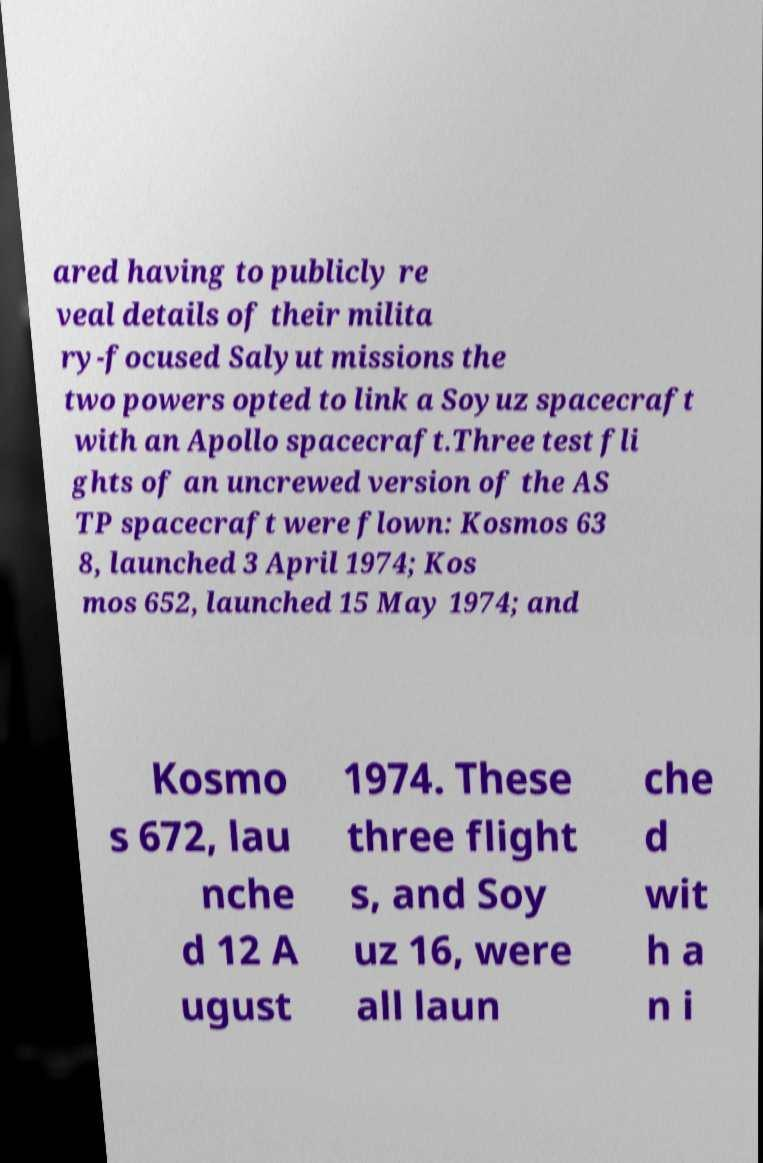Please read and relay the text visible in this image. What does it say? ared having to publicly re veal details of their milita ry-focused Salyut missions the two powers opted to link a Soyuz spacecraft with an Apollo spacecraft.Three test fli ghts of an uncrewed version of the AS TP spacecraft were flown: Kosmos 63 8, launched 3 April 1974; Kos mos 652, launched 15 May 1974; and Kosmo s 672, lau nche d 12 A ugust 1974. These three flight s, and Soy uz 16, were all laun che d wit h a n i 